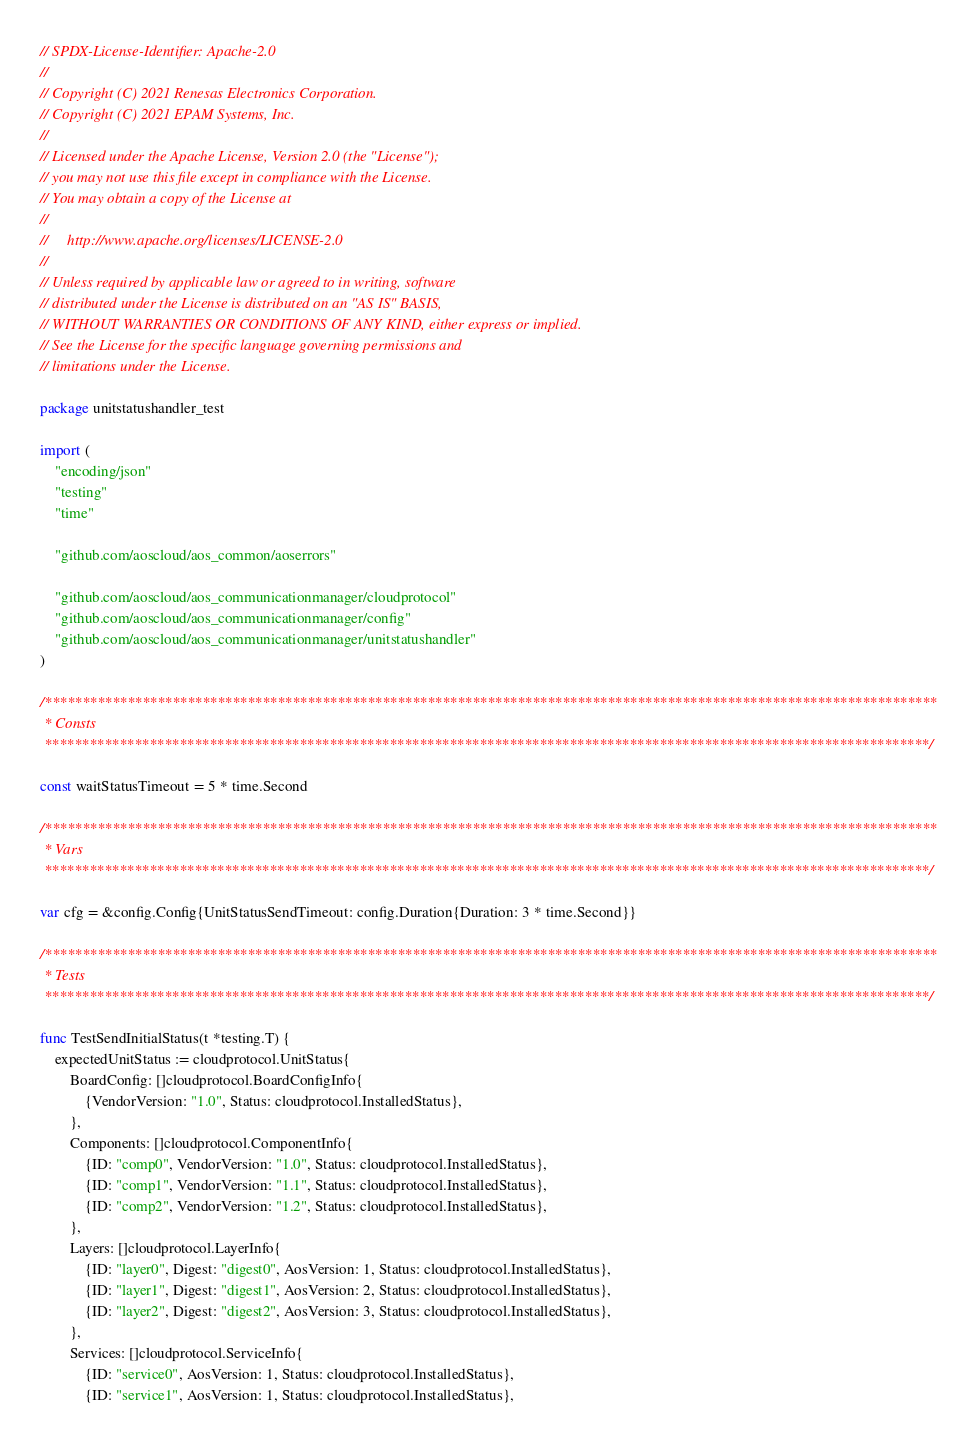Convert code to text. <code><loc_0><loc_0><loc_500><loc_500><_Go_>// SPDX-License-Identifier: Apache-2.0
//
// Copyright (C) 2021 Renesas Electronics Corporation.
// Copyright (C) 2021 EPAM Systems, Inc.
//
// Licensed under the Apache License, Version 2.0 (the "License");
// you may not use this file except in compliance with the License.
// You may obtain a copy of the License at
//
//     http://www.apache.org/licenses/LICENSE-2.0
//
// Unless required by applicable law or agreed to in writing, software
// distributed under the License is distributed on an "AS IS" BASIS,
// WITHOUT WARRANTIES OR CONDITIONS OF ANY KIND, either express or implied.
// See the License for the specific language governing permissions and
// limitations under the License.

package unitstatushandler_test

import (
	"encoding/json"
	"testing"
	"time"

	"github.com/aoscloud/aos_common/aoserrors"

	"github.com/aoscloud/aos_communicationmanager/cloudprotocol"
	"github.com/aoscloud/aos_communicationmanager/config"
	"github.com/aoscloud/aos_communicationmanager/unitstatushandler"
)

/***********************************************************************************************************************
 * Consts
 **********************************************************************************************************************/

const waitStatusTimeout = 5 * time.Second

/***********************************************************************************************************************
 * Vars
 **********************************************************************************************************************/

var cfg = &config.Config{UnitStatusSendTimeout: config.Duration{Duration: 3 * time.Second}}

/***********************************************************************************************************************
 * Tests
 **********************************************************************************************************************/

func TestSendInitialStatus(t *testing.T) {
	expectedUnitStatus := cloudprotocol.UnitStatus{
		BoardConfig: []cloudprotocol.BoardConfigInfo{
			{VendorVersion: "1.0", Status: cloudprotocol.InstalledStatus},
		},
		Components: []cloudprotocol.ComponentInfo{
			{ID: "comp0", VendorVersion: "1.0", Status: cloudprotocol.InstalledStatus},
			{ID: "comp1", VendorVersion: "1.1", Status: cloudprotocol.InstalledStatus},
			{ID: "comp2", VendorVersion: "1.2", Status: cloudprotocol.InstalledStatus},
		},
		Layers: []cloudprotocol.LayerInfo{
			{ID: "layer0", Digest: "digest0", AosVersion: 1, Status: cloudprotocol.InstalledStatus},
			{ID: "layer1", Digest: "digest1", AosVersion: 2, Status: cloudprotocol.InstalledStatus},
			{ID: "layer2", Digest: "digest2", AosVersion: 3, Status: cloudprotocol.InstalledStatus},
		},
		Services: []cloudprotocol.ServiceInfo{
			{ID: "service0", AosVersion: 1, Status: cloudprotocol.InstalledStatus},
			{ID: "service1", AosVersion: 1, Status: cloudprotocol.InstalledStatus},</code> 